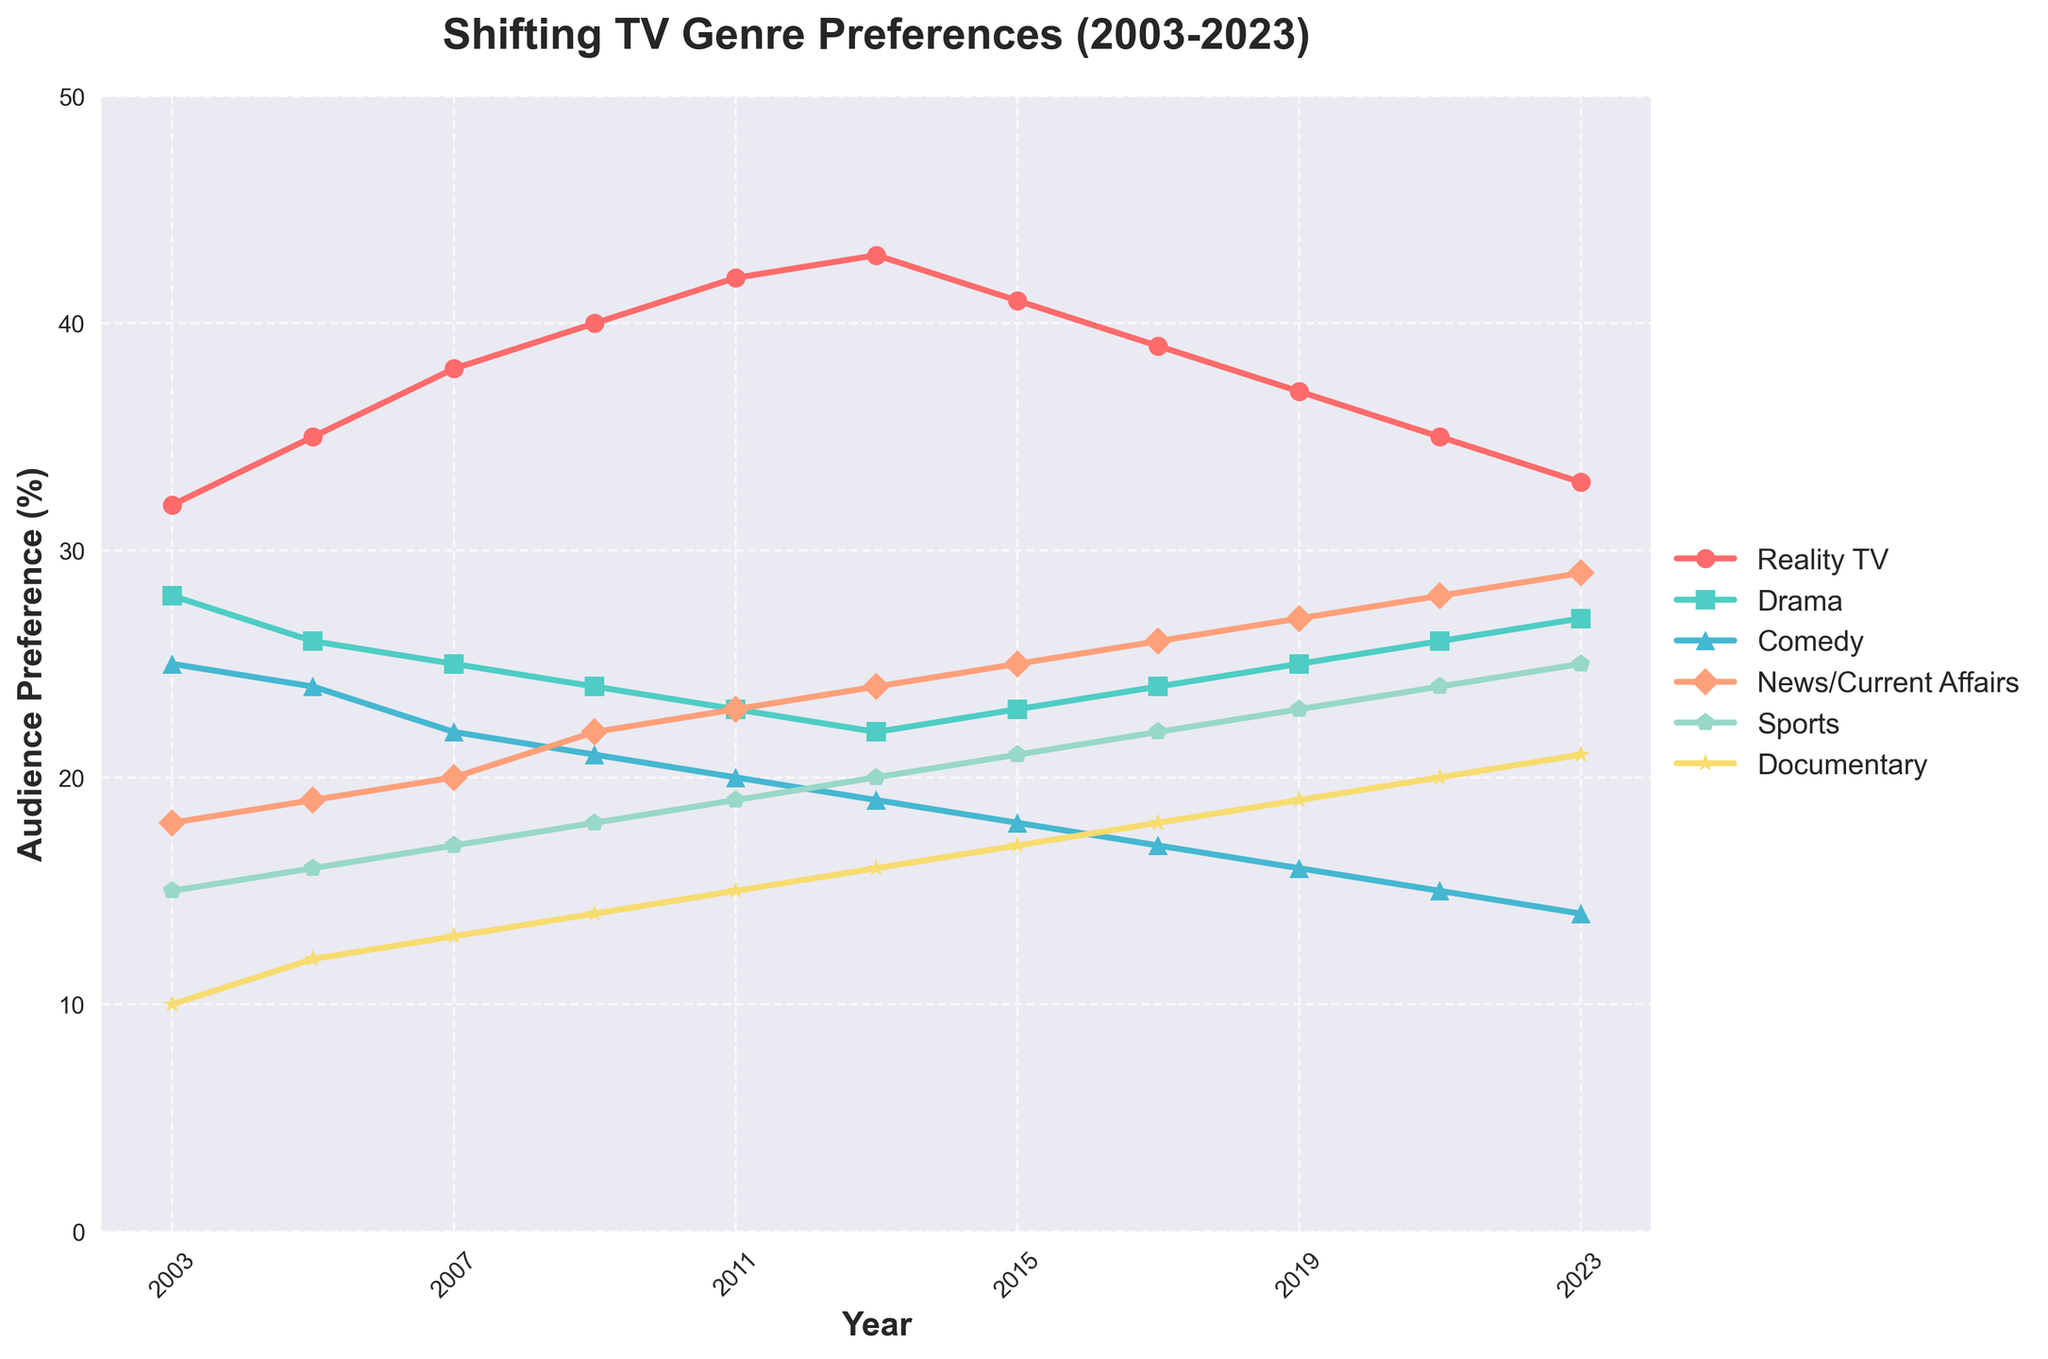What is the most preferred TV genre in 2003 and 2023? In 2003, the highest line is for Reality TV (32%), followed by Drama (28%), while in 2023, the highest is News/Current Affairs (29%), followed by Reality TV (33%).
Answer: Reality TV in 2003, News/Current Affairs in 2023 How has the preference for Reality TV changed from 2003 to 2023? The preference for Reality TV started at 32% in 2003 and fluctuated upward until peaking at 43% in 2013, then declined steadily to 33% in 2023.
Answer: Peaked then declined Which TV genre saw the greatest increase in preference from 2003 to 2023? By comparing the starting and ending points of all genres, News/Current Affairs increased from 18% to 29%, which is the highest increase of 11 percentage points.
Answer: News/Current Affairs How do the preferences for Drama and Comedy in 2023 compare to those in 2003? Drama's preference dropped from 28% in 2003 to 27% in 2023, while Comedy's preference fell from 25% to 14%. Both genres have seen a decrease, with Comedy having a larger drop.
Answer: Both decreased, larger drop for Comedy What is the combined preference for News/Current Affairs and Sports in 2023? Adding the preferences for News/Current Affairs (29%) and Sports (25%) in 2023 gives a combined preference of 54%.
Answer: 54% What significant trend is visible in the preference for Documentary from 2003 to 2023? Documentary preference shows a consistent upward trend, beginning at 10% in 2003 and steadily increasing to 21% in 2023, essentially doubling.
Answer: Consistently upward Compare the preference patterns for Sports and Comedy over the two decades. Sports preference steadily increased each year from 15% in 2003 to 25% in 2023, while Comedy showed a steady decline from 25% to 14% over the same period, indicating contrasting trends.
Answer: Sports increased, Comedy decreased What is the second most preferred genre in 2015? In 2015, the second highest line is for News/Current Affairs at 25%, behind Reality TV at 41%.
Answer: News/Current Affairs Which genre's preference remained closest to 20% throughout the two decades? Documentary, starting from 10% and ending at 21%, showed preference values within 10-21% range. Drama, starting from 28% and ending at 27%, fluctuated near 20% but was mostly above.
Answer: Documentary How does the preference for Reality TV change compared to Documentary over the two decades? Reality TV showed an initial rise, peaked, then declined from 32% in 2003 to 33% in 2023. Documentary, on the other hand, showed a steady rise from 10% to 21% over the same period.
Answer: Reality TV peaked then declined, Documentary steadily increased 